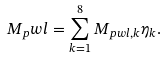Convert formula to latex. <formula><loc_0><loc_0><loc_500><loc_500>M _ { p } w l = \sum _ { k = 1 } ^ { 8 } M _ { p w l , k } \eta _ { k } .</formula> 